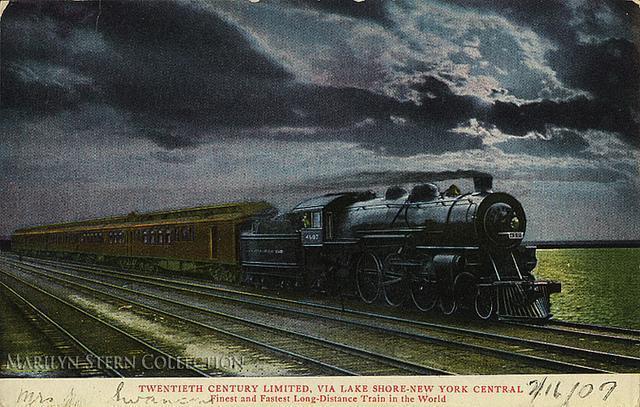How many bikes are here?
Give a very brief answer. 0. 